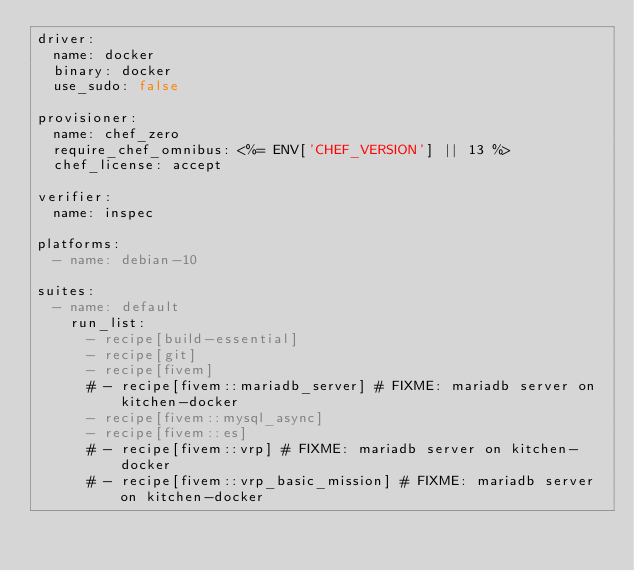<code> <loc_0><loc_0><loc_500><loc_500><_YAML_>driver:
  name: docker
  binary: docker
  use_sudo: false

provisioner:
  name: chef_zero
  require_chef_omnibus: <%= ENV['CHEF_VERSION'] || 13 %>
  chef_license: accept

verifier:
  name: inspec

platforms:
  - name: debian-10

suites:
  - name: default
    run_list:
      - recipe[build-essential]
      - recipe[git]
      - recipe[fivem]
      # - recipe[fivem::mariadb_server] # FIXME: mariadb server on kitchen-docker
      - recipe[fivem::mysql_async]
      - recipe[fivem::es]
      # - recipe[fivem::vrp] # FIXME: mariadb server on kitchen-docker
      # - recipe[fivem::vrp_basic_mission] # FIXME: mariadb server on kitchen-docker
</code> 